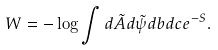Convert formula to latex. <formula><loc_0><loc_0><loc_500><loc_500>W = - \log \int d \tilde { A } d \tilde { \psi } d b d c e ^ { - S } .</formula> 